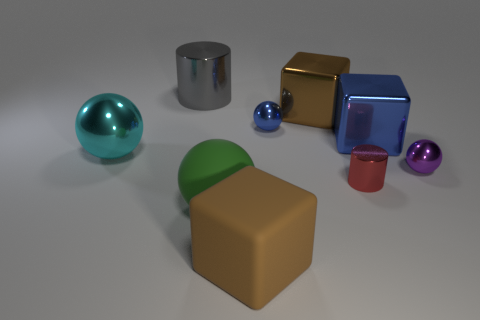Are the tiny red cylinder and the blue sphere made of the same material?
Offer a terse response. Yes. There is a rubber object that is right of the green matte thing; how many big brown things are on the right side of it?
Offer a very short reply. 1. Does the small thing in front of the purple thing have the same color as the big rubber cube?
Offer a very short reply. No. What number of things are cylinders or things behind the big matte cube?
Ensure brevity in your answer.  8. Does the tiny object that is to the left of the brown metal object have the same shape as the large rubber thing in front of the green ball?
Offer a very short reply. No. Are there any other things of the same color as the matte block?
Keep it short and to the point. Yes. There is a gray thing that is the same material as the cyan object; what shape is it?
Keep it short and to the point. Cylinder. What material is the ball that is on the left side of the red metal object and to the right of the large green sphere?
Give a very brief answer. Metal. Is there anything else that is the same size as the green ball?
Your answer should be very brief. Yes. Does the matte cube have the same color as the rubber ball?
Your answer should be very brief. No. 